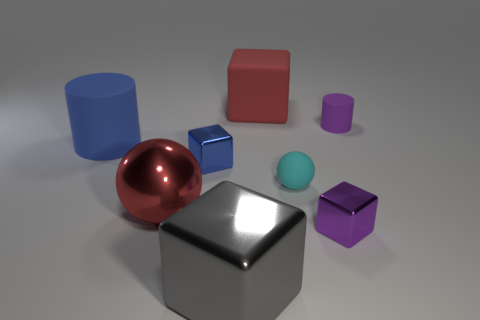There is a metal block to the left of the gray thing; is its color the same as the large matte cylinder?
Your response must be concise. Yes. There is a thing that is the same color as the big cylinder; what is its size?
Offer a terse response. Small. Do the rubber block and the large sphere have the same color?
Offer a very short reply. Yes. Are there any things that have the same color as the rubber block?
Provide a short and direct response. Yes. Is the small purple cylinder made of the same material as the red object on the left side of the tiny blue block?
Make the answer very short. No. The big rubber cylinder is what color?
Offer a very short reply. Blue. What shape is the red object that is to the left of the red block?
Your answer should be compact. Sphere. How many red things are either shiny things or large shiny objects?
Give a very brief answer. 1. There is a large block that is made of the same material as the big blue cylinder; what color is it?
Your answer should be compact. Red. Do the rubber ball and the large thing that is to the right of the big gray block have the same color?
Make the answer very short. No. 